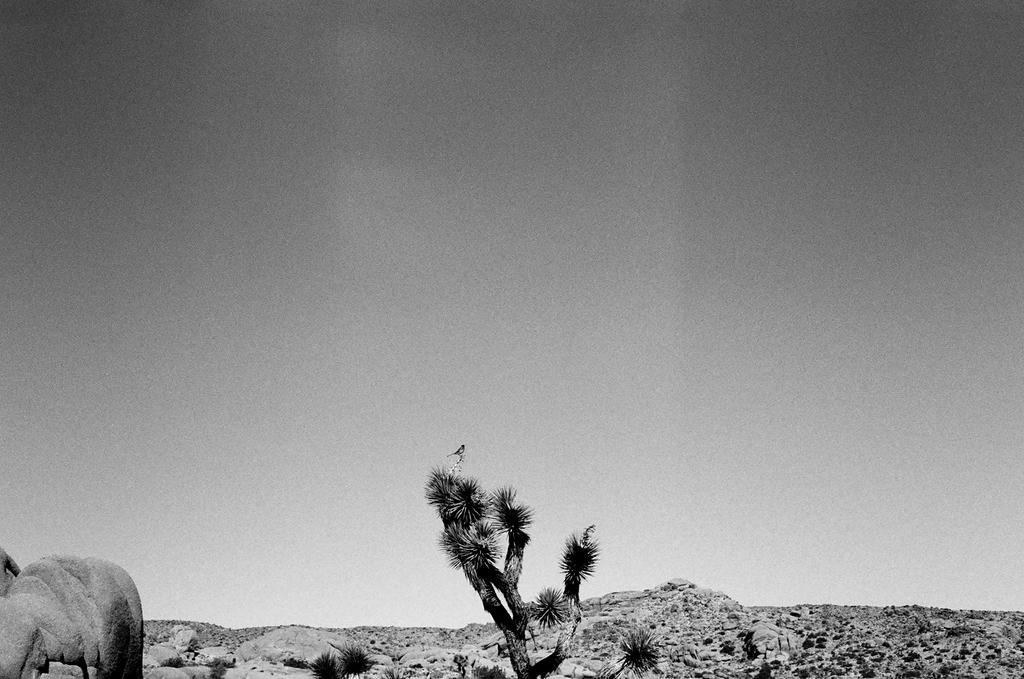What type of picture is in the image? The image contains a black and white picture. What natural element can be seen in the picture? There is a tree in the picture. What type of objects are present in the picture? There are stones in the picture. What part of the natural environment is visible in the picture? The sky is visible in the picture. What type of animal can be seen in the picture? There is a bird in the picture. What type of art can be seen on the van in the image? There is no van present in the image, so it is not possible to determine what type of art might be on it. 